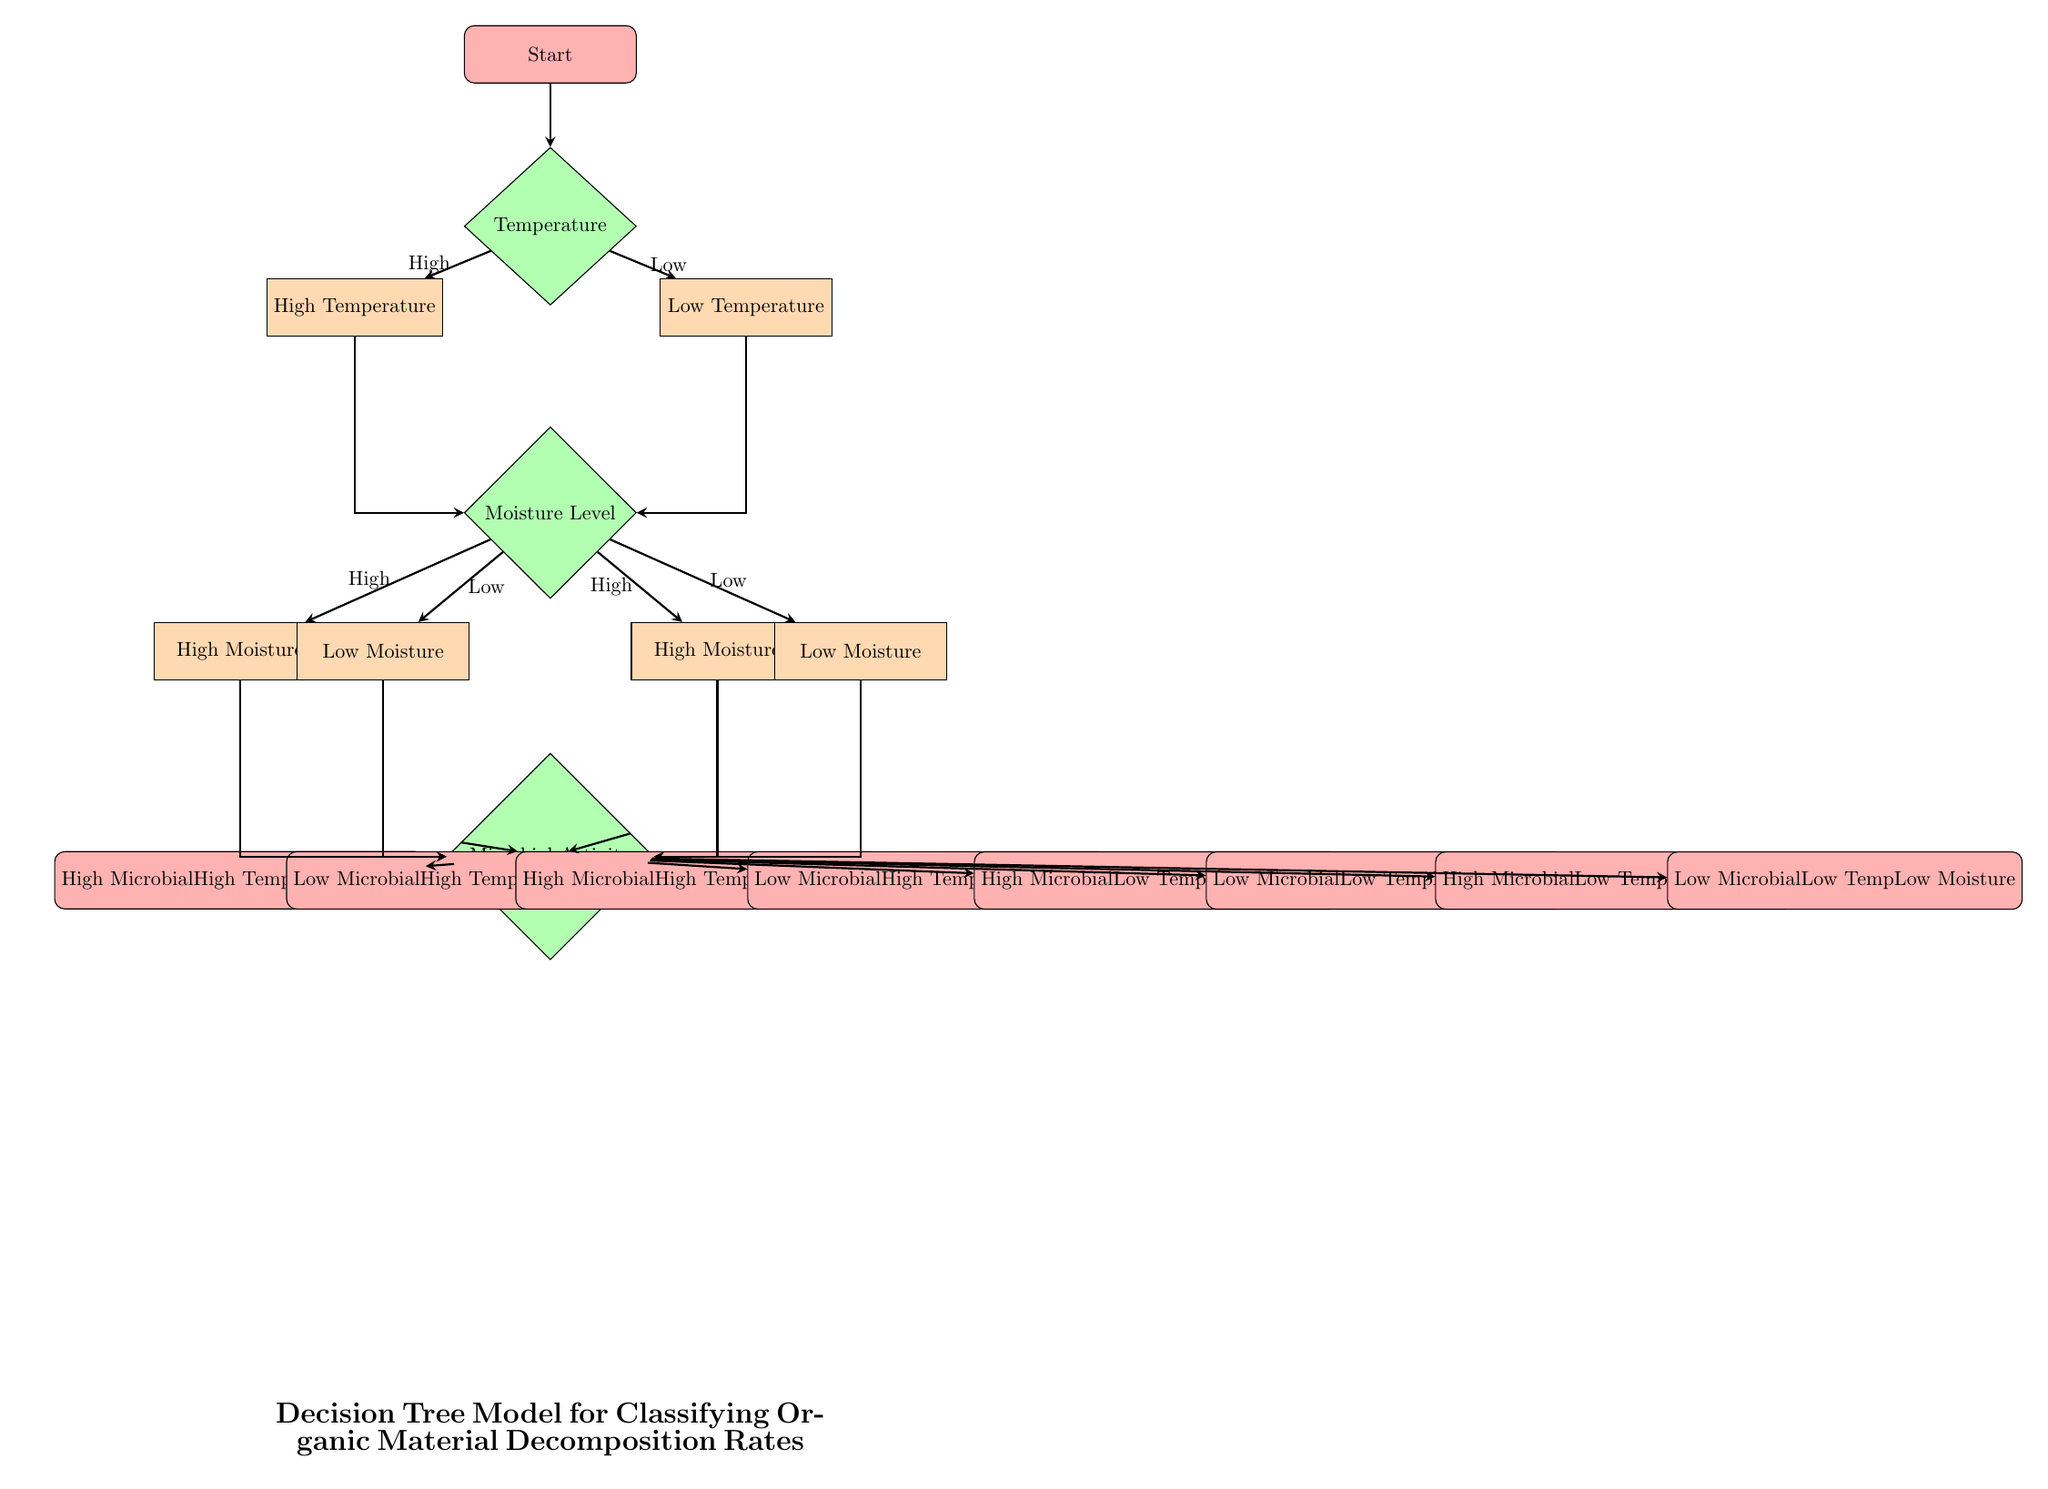What is the first decision in the diagram? The first decision is about the temperature, where the diagram branches into high and low temperature.
Answer: Temperature How many end nodes are in the decision tree? As per the diagram, there are 8 end nodes representing different combinations of microbial activity, temperature, and moisture levels leading to classifications.
Answer: 8 What are the two options from the Temperature decision node? The decisions stemming from the Temperature node are "High" and "Low," indicating the two possible temperature levels that affect decomposition rates.
Answer: High, Low What classification is reached if the temperature is low and moisture is high with high microbial activity? The classification for this pathway, where temperature is low, moisture is high, and microbial activity is high, is “High Microbial Low Temp High Moisture.”
Answer: High Microbial Low Temp High Moisture If the moisture is low, what are the two microbial activity outcomes possible? The microbial activity outcomes possible when moisture is low are either high microbial activity or low microbial activity, leading to further classification of decomposition rates.
Answer: High Microbial, Low Microbial What happens to groups with high temperature and high microbial activity? These groups are classified as having high decomposition rates and are further distinguished based on moisture levels, leading to four possible classifications.
Answer: High decomposition Which node occurs after the Moisture Level decision? The node that follows the Moisture Level decision is the Microbial Activity node, where decisions continue to refine the classification based on microbial influence.
Answer: Microbial Activity What does the classification node "Low Microbial Low Temp Low Moisture" indicate? This classification indicates the scenario where all factors—microbial activity, temperature, and moisture—are low, resulting in a specific outcome for organic material decomposition rates.
Answer: Low Microbial Low Temp Low Moisture 